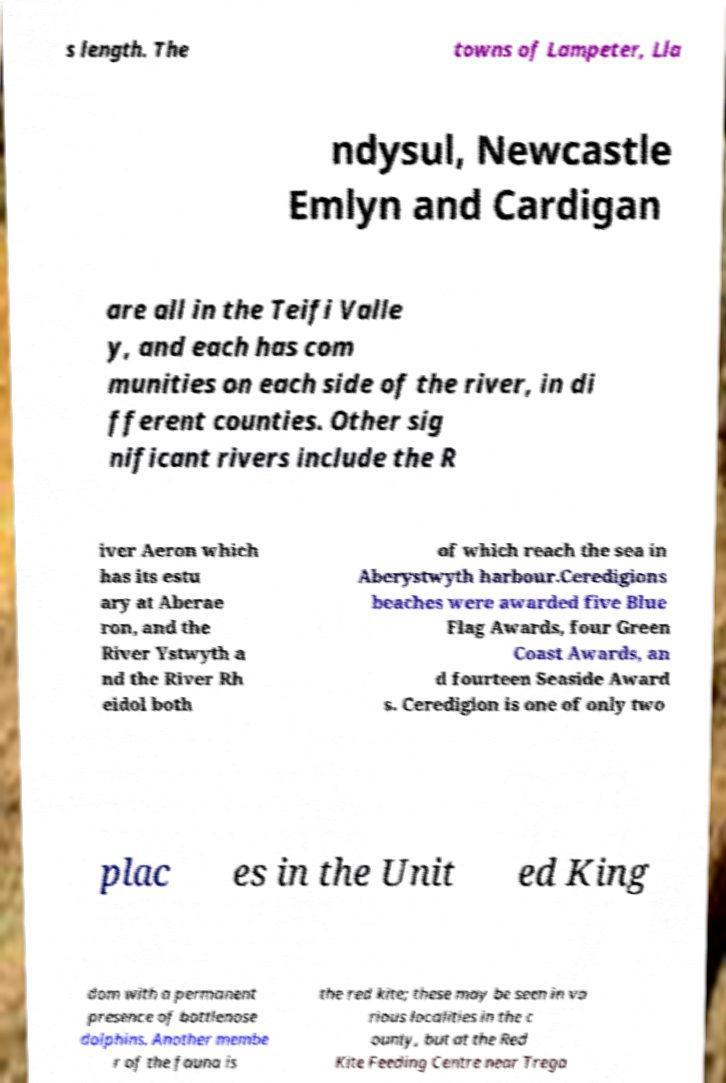Please identify and transcribe the text found in this image. s length. The towns of Lampeter, Lla ndysul, Newcastle Emlyn and Cardigan are all in the Teifi Valle y, and each has com munities on each side of the river, in di fferent counties. Other sig nificant rivers include the R iver Aeron which has its estu ary at Aberae ron, and the River Ystwyth a nd the River Rh eidol both of which reach the sea in Aberystwyth harbour.Ceredigions beaches were awarded five Blue Flag Awards, four Green Coast Awards, an d fourteen Seaside Award s. Ceredigion is one of only two plac es in the Unit ed King dom with a permanent presence of bottlenose dolphins. Another membe r of the fauna is the red kite; these may be seen in va rious localities in the c ounty, but at the Red Kite Feeding Centre near Trega 